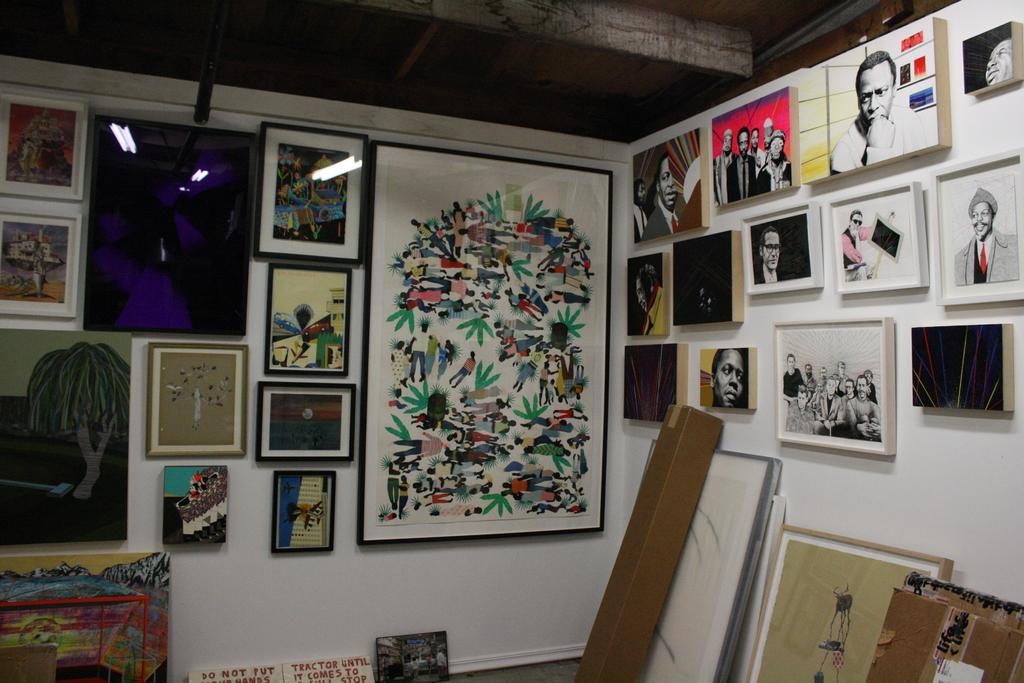What is attached to the wall in the foreground of the image? There are frames attached to the wall in the foreground of the image. What else can be seen in the foreground of the image? There are cardboard boxes in the foreground of the image. What alley can be seen in the background of the image? There is no alley present in the image; it only features frames on the wall and cardboard boxes in the foreground. Can you tell me which actor is standing next to the cardboard boxes? There are no actors present in the image; it only features frames on the wall and cardboard boxes in the foreground. 